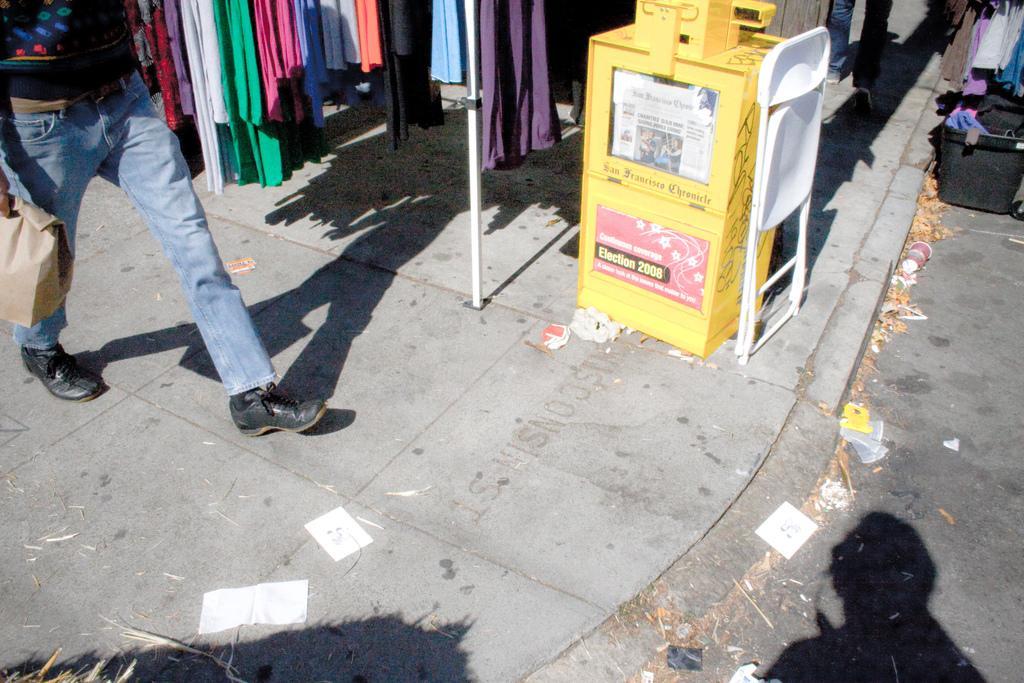Please provide a concise description of this image. In the left top I can see a person is holding a bag in hand is walking on the road. In the background I can see a chair, bags and clothes are hanged on a stand. This image is taken during a day. 